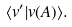<formula> <loc_0><loc_0><loc_500><loc_500>\langle v ^ { \prime } | v ( A ) \rangle .</formula> 